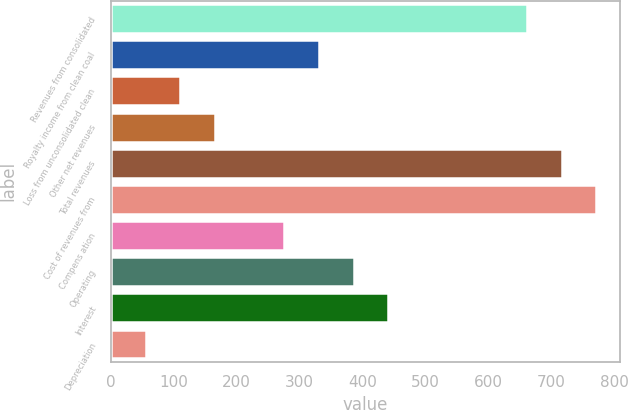<chart> <loc_0><loc_0><loc_500><loc_500><bar_chart><fcel>Revenues from consolidated<fcel>Royalty income from clean coal<fcel>Loss from unconsolidated clean<fcel>Other net revenues<fcel>Total revenues<fcel>Cost of revenues from<fcel>Compens ation<fcel>Operating<fcel>Interest<fcel>Depreciation<nl><fcel>661.1<fcel>330.62<fcel>110.3<fcel>165.38<fcel>716.18<fcel>771.26<fcel>275.54<fcel>385.7<fcel>440.78<fcel>55.22<nl></chart> 